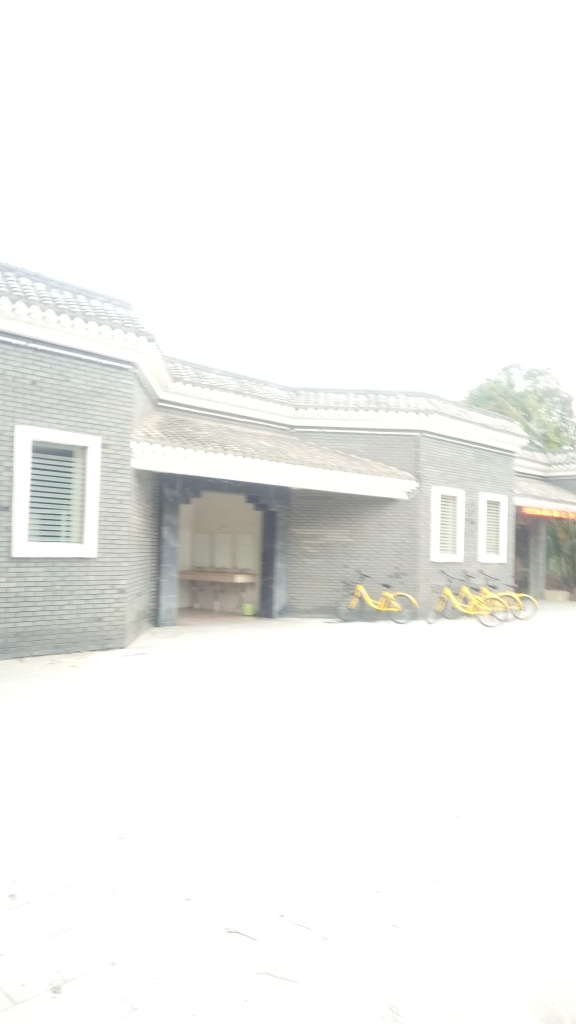What kind of building is shown in this image? The image depicts a structure that appears to be a residential building, featuring a traditional style with a sloping tiled roof and an open gateway that could suggest a communal or shared space. 